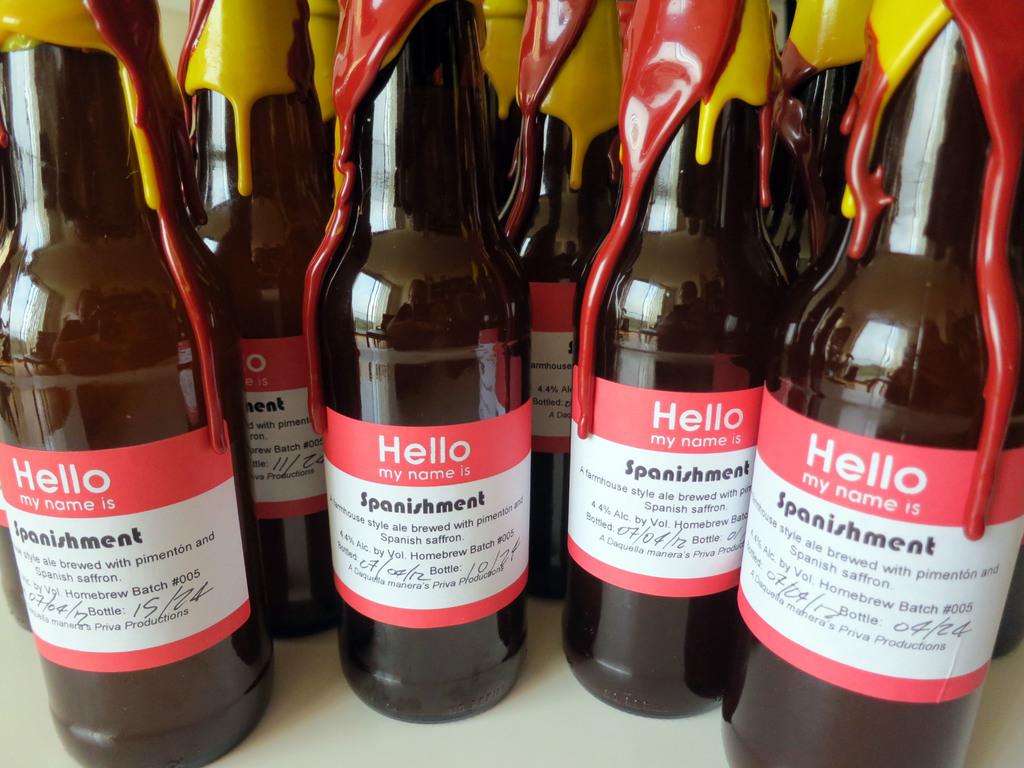What is the name of the wine?
Your answer should be compact. Spanishment. 